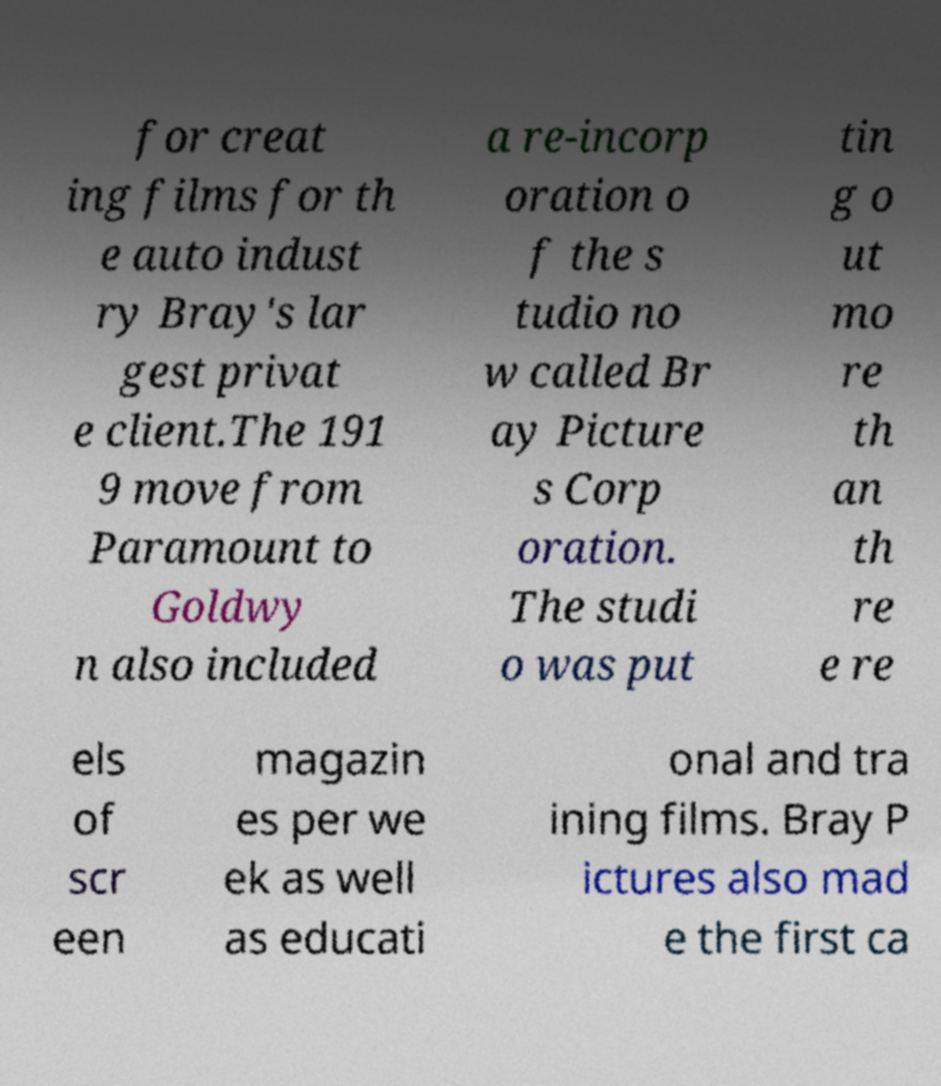There's text embedded in this image that I need extracted. Can you transcribe it verbatim? for creat ing films for th e auto indust ry Bray's lar gest privat e client.The 191 9 move from Paramount to Goldwy n also included a re-incorp oration o f the s tudio no w called Br ay Picture s Corp oration. The studi o was put tin g o ut mo re th an th re e re els of scr een magazin es per we ek as well as educati onal and tra ining films. Bray P ictures also mad e the first ca 